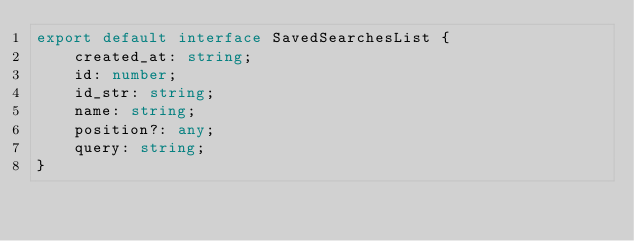Convert code to text. <code><loc_0><loc_0><loc_500><loc_500><_TypeScript_>export default interface SavedSearchesList {
    created_at: string;
    id: number;
    id_str: string;
    name: string;
    position?: any;
    query: string;
}
</code> 